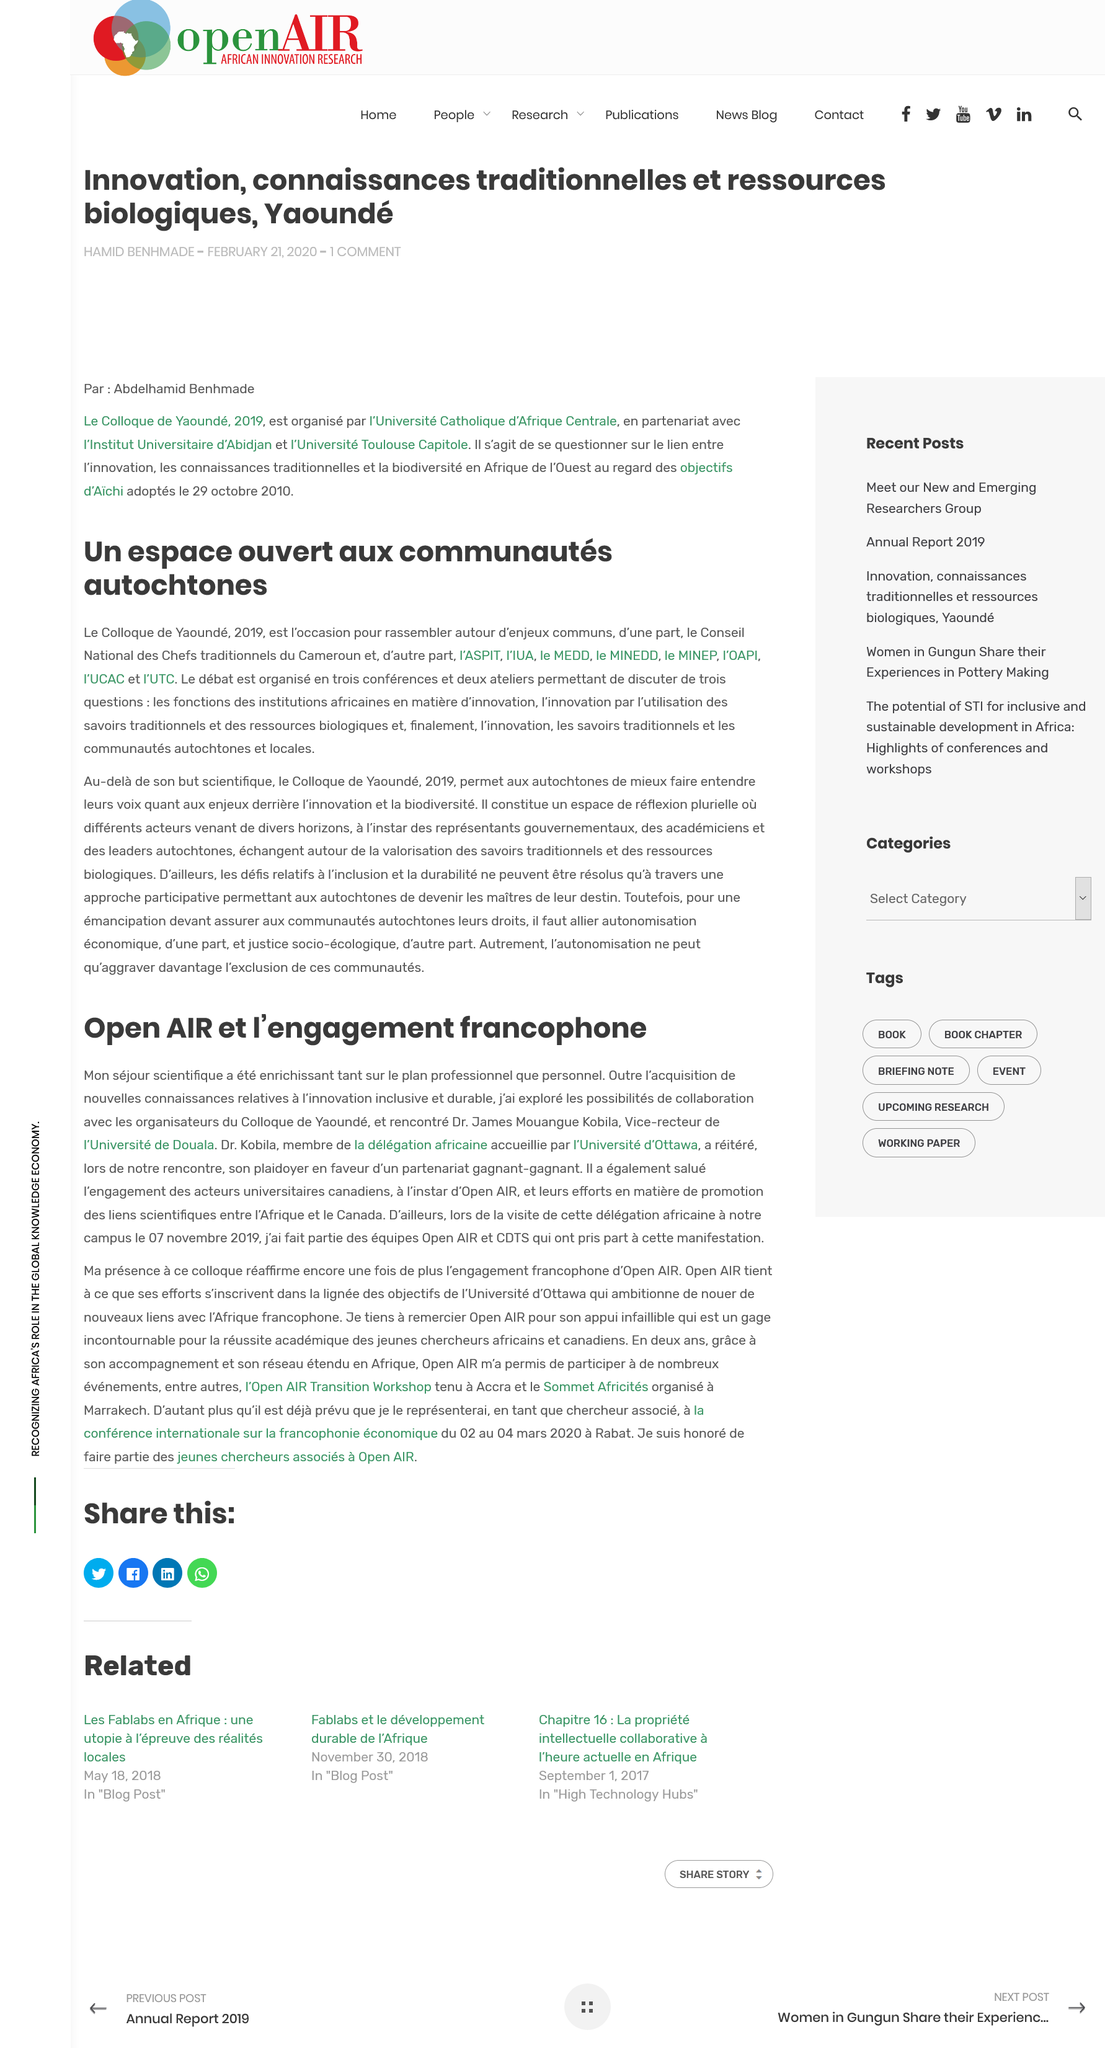Indicate a few pertinent items in this graphic. Le débat abordera trois questions. Dr. James Mouangue Kobila is the Vice-Rector of Douala University. Dr. Kobila is a member of the African delegation. A total of three conferences and two workshops have engaged in the debate. The goal of the Yaounde Colloquium is to bring together individuals with shared concerns to discuss and address common issues. 